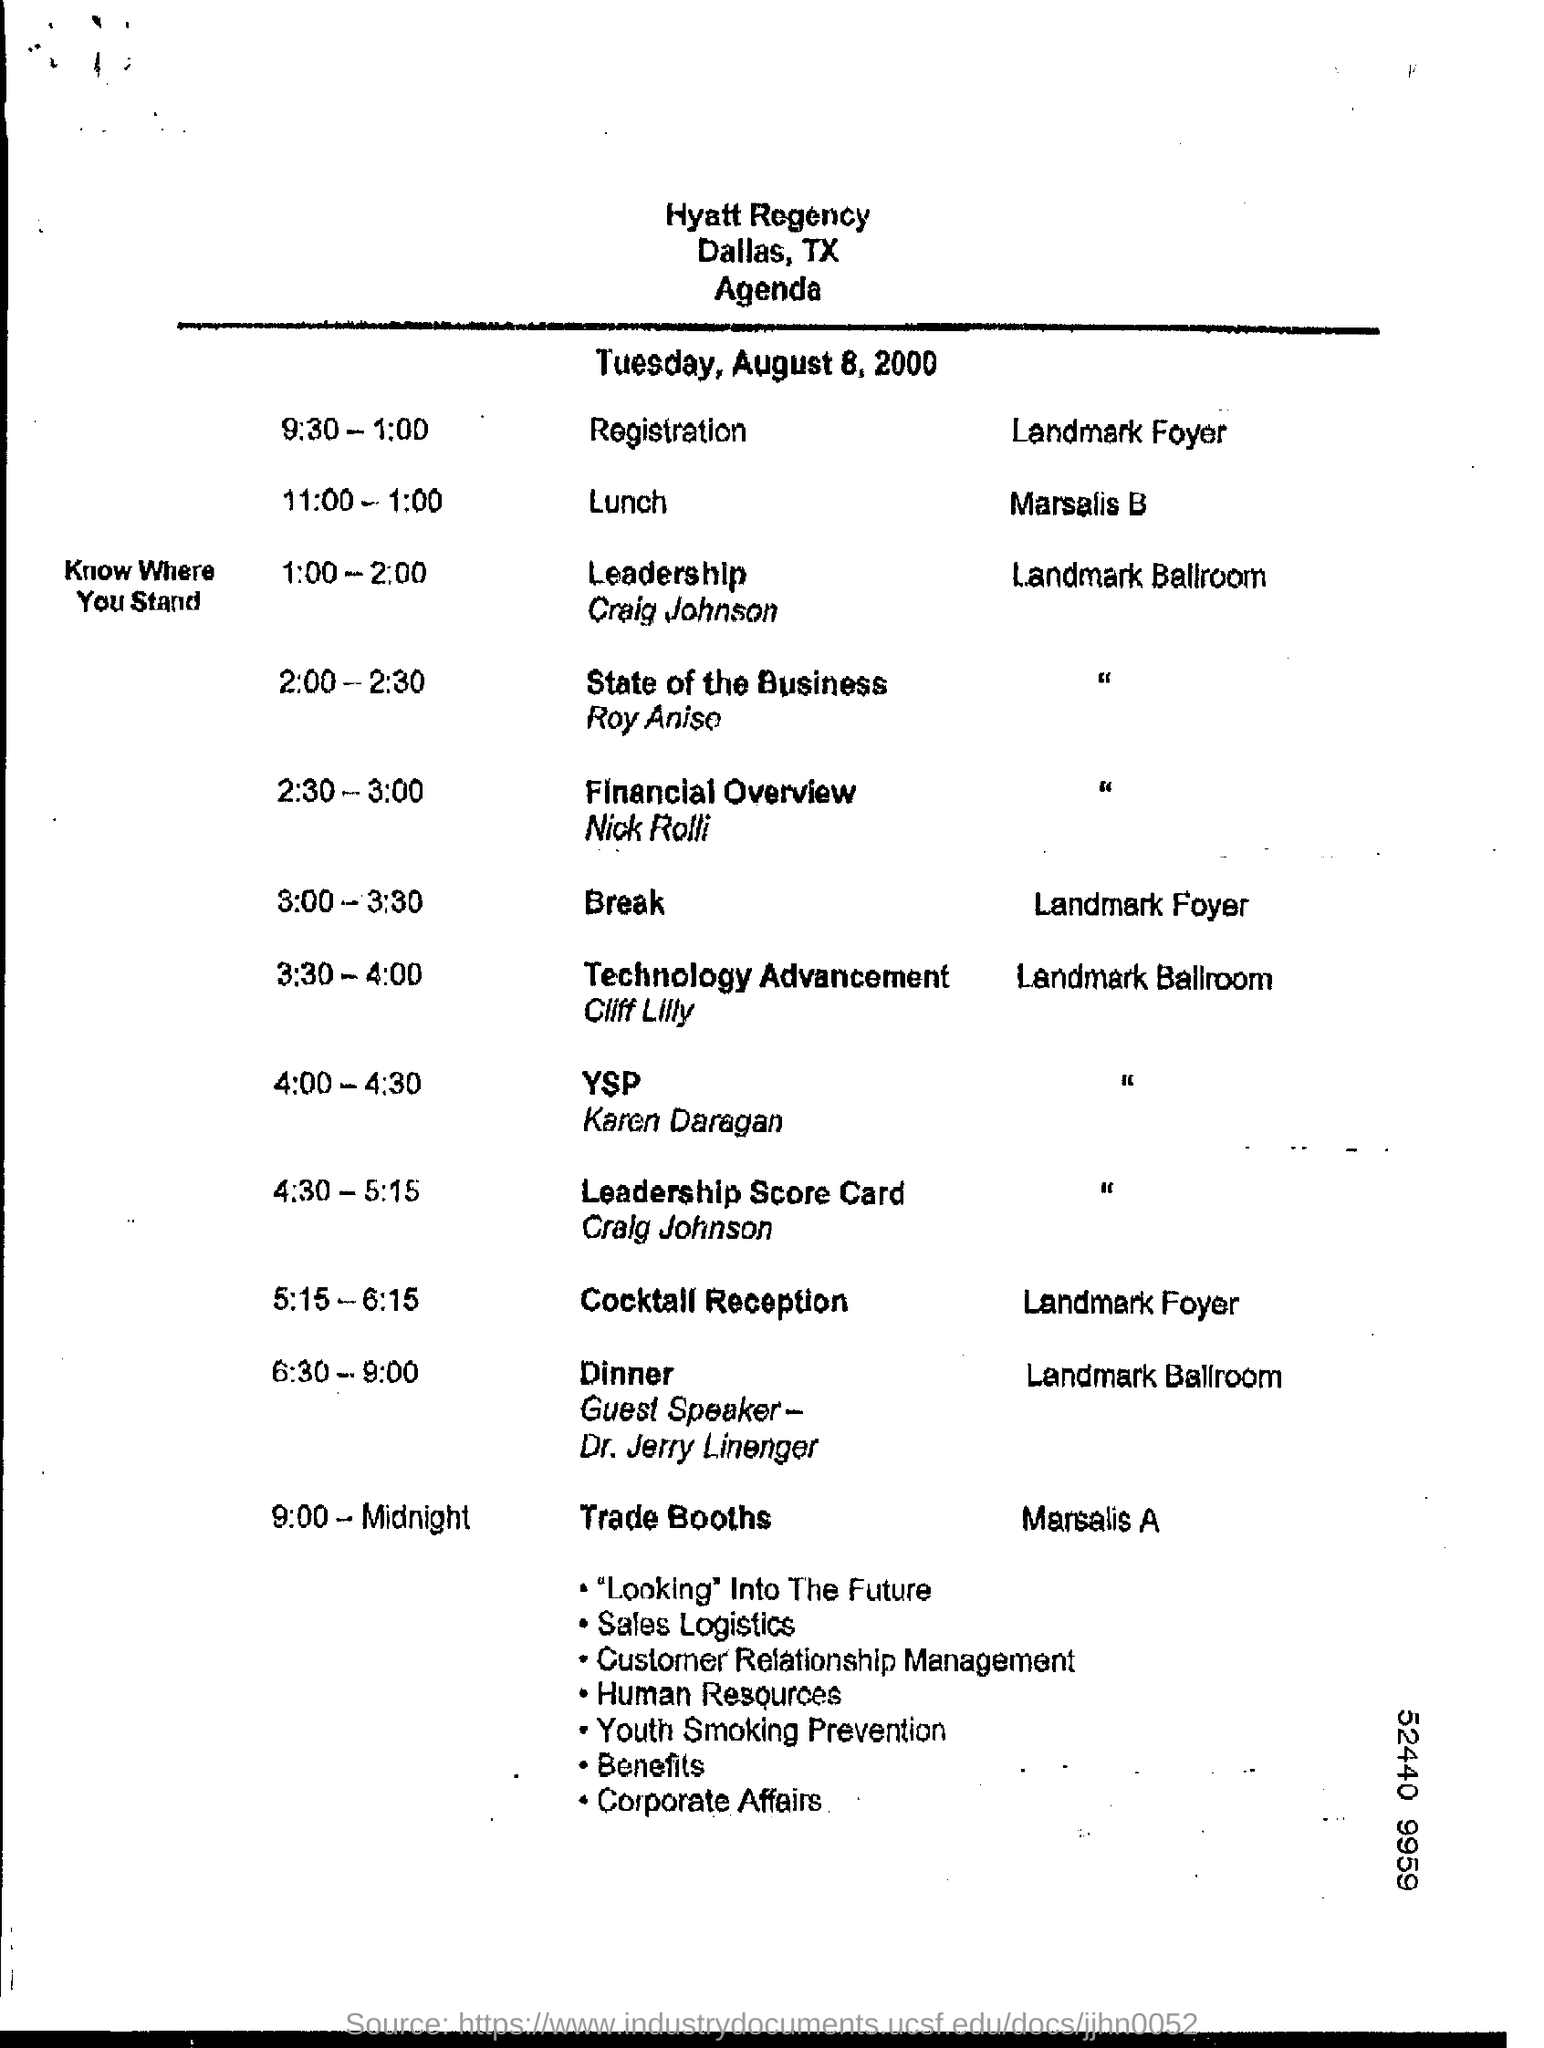When is the Break?
Provide a succinct answer. 3:00 - 3:30. When is the Registration?
Provide a succinct answer. 9:30 - 1:00. 